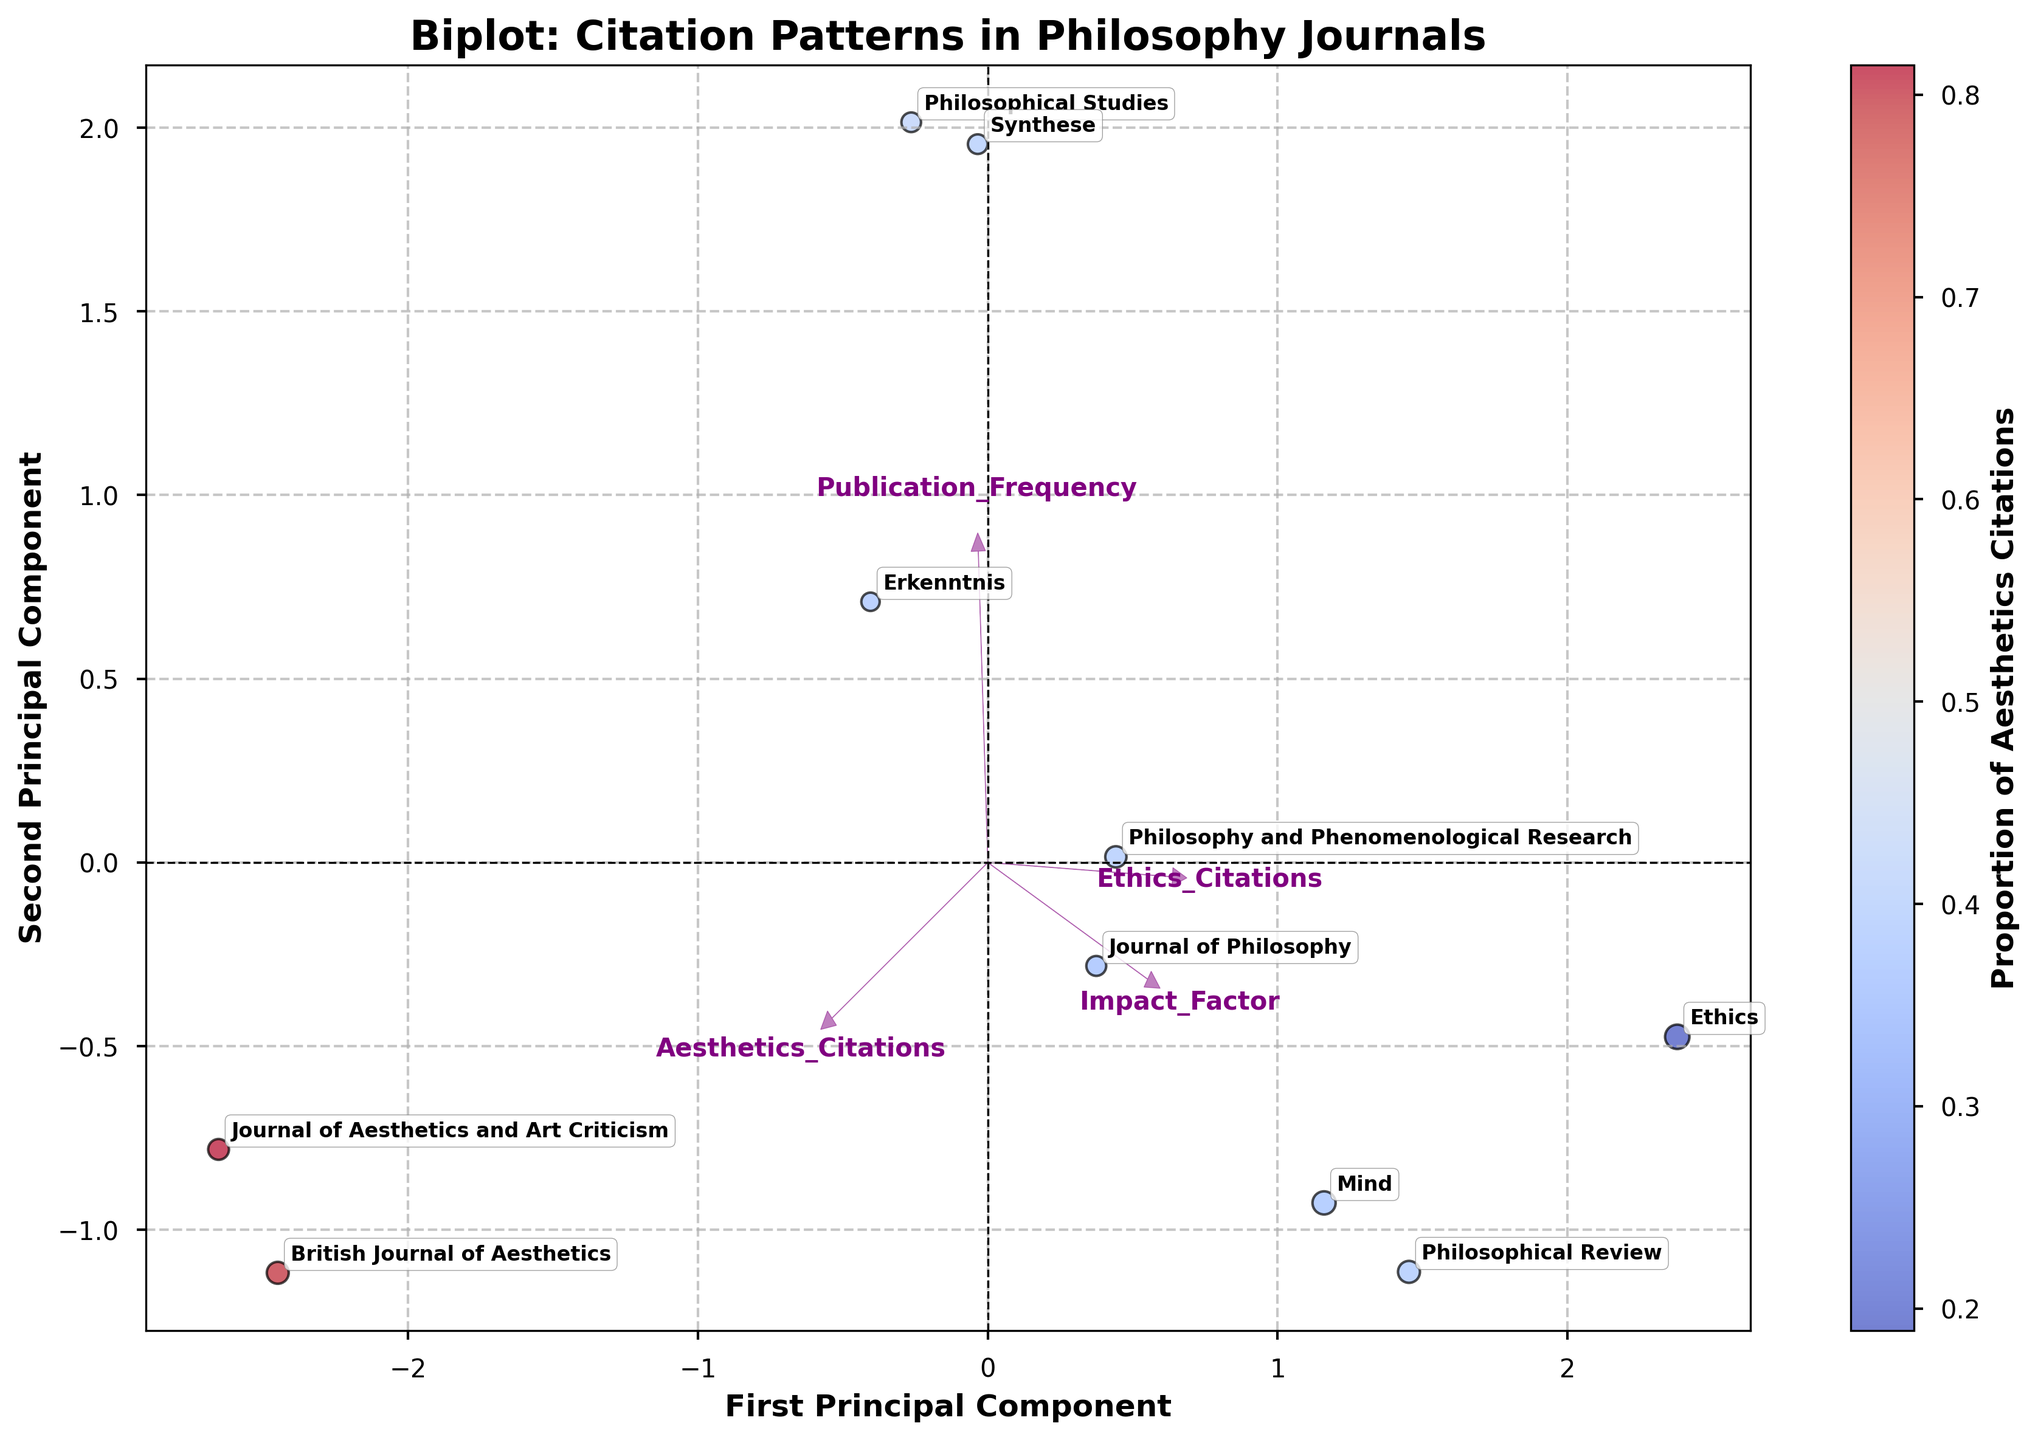What is the title of the plot? The title is located at the top of the plot and is prominently displayed
Answer: Biplot: Citation Patterns in Philosophy Journals Which journal has the highest proportion of aesthetics citations? The colorbar indicates the proportion of aesthetics citations. The journal with the deepest color towards blue has the highest proportion
Answer: British Journal of Aesthetics How often is "Ethics" published annually? The label on or near the data point for "Ethics" shows its publication frequency converted to a numerical scale. "Quarterly" would be 4 times a year
Answer: 4 times a year Which journal has the highest combined citations for both aesthetics and ethics? Check the size of the markers, as larger markers indicate a higher sum of citations (aesthetics + ethics)
Answer: Mind What is the X-axis labeled as? The X-axis label can be found at the bottom of the plot, indicating the first principal component
Answer: First Principal Component Which feature vector points the closest towards the first principal component? Identify the black arrows, and the feature with an arrow pointing most closely along the X-axis represents the first principal component
Answer: Aesthetics_Citations Between "Philosophical Review" and "Journal of Aesthetics and Art Criticism," which one has higher ethics citations? Locate both journals on the plot and use the color gradient to determine the proportion of citations; darker red meaning more ethics citations
Answer: Philosophical Review What is represented by the color gradient on the scatter points? The color gradient, as shown by the colorbar, represents the proportion of aesthetics citations out of the total citations
Answer: Proportion of Aesthetics Citations Which component explains more variation, the first or the second principal component? Observe which axis has the larger spread of data points along it, which typically indicates more explained variance
Answer: First Principal Component Are there any journals that are monthly publications? If so, name one. Identify the journals with a corresponding data point arrow, and look for the term "Monthly" indicated by frequency
Answer: Philosophical Studies, Synthese 